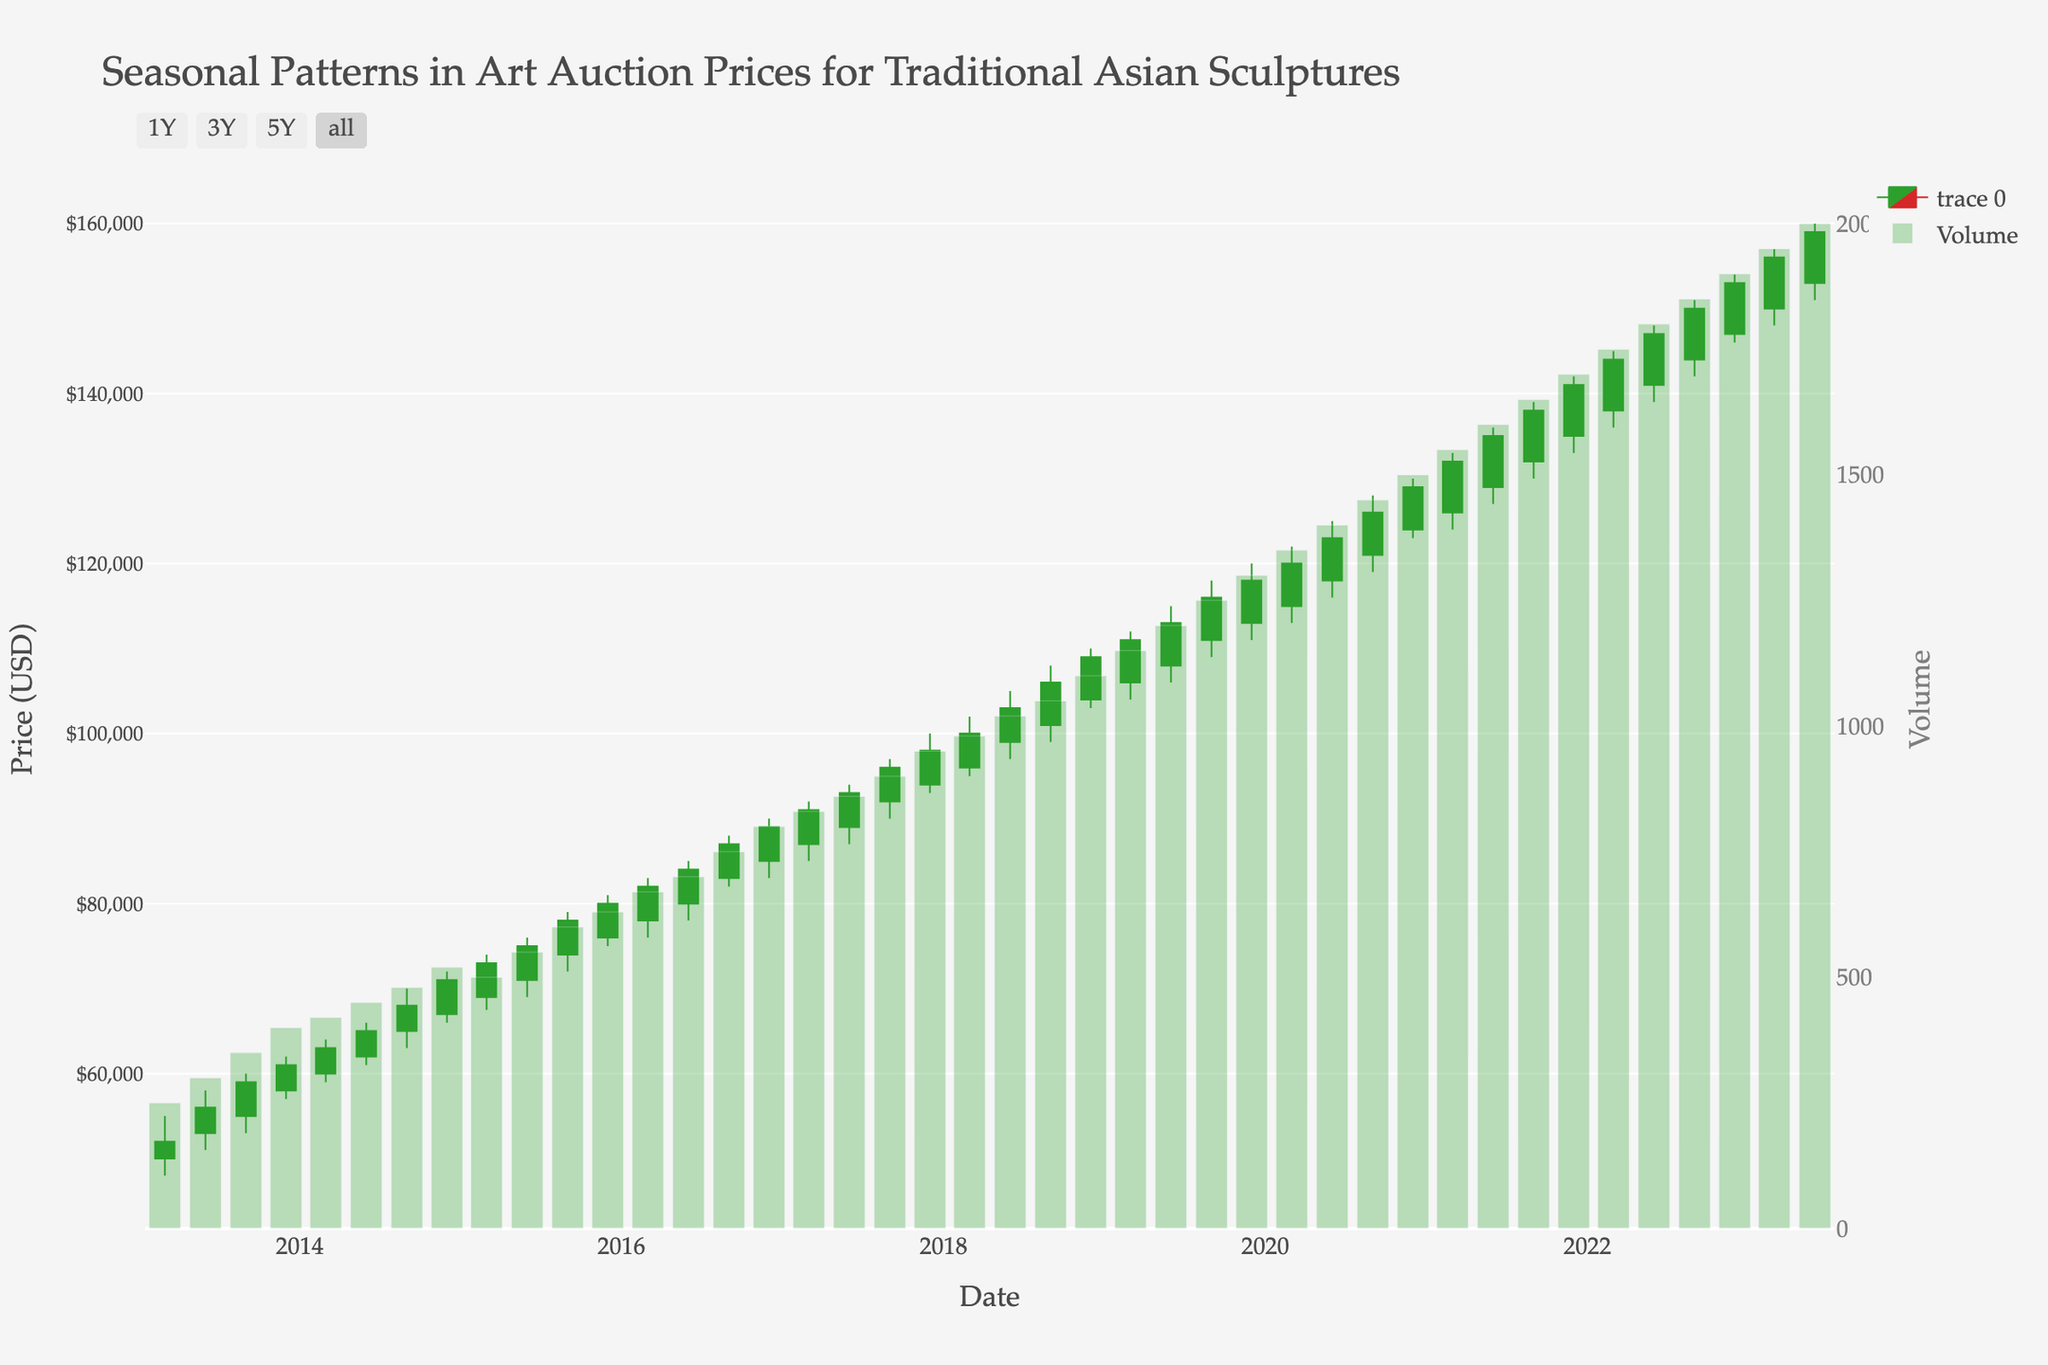What is the title of the figure? The title is located at the top center of the figure. It directly states the main theme of the chart.
Answer: Seasonal Patterns in Art Auction Prices for Traditional Asian Sculptures What are the labels on the x-axis and y-axis? The x-axis label is for time-related information while the y-axis label pertains to price data. These labels are found below each axis.
Answer: Date and Price (USD) How does the price trend from 2013 to 2023? By observing the movement of the candlesticks from 2013 to 2023, we can see a general upward trend with minor fluctuations.
Answer: The price generally increases What is the volume of sales in December 2022? The bar corresponding to December 2022 will show the volume height, and hovering over it reveals the exact volume value.
Answer: 1900 Describe the color coding for the candlesticks. The figure uses green for increasing (Open to Close) prices and red for decreasing prices; this is consistent across the plot.
Answer: Green for increasing, red for decreasing When did the volume surpass 1300? We need to look for the first occurrence where a bar height exceeds the 1300 mark on the volume axis.
Answer: December 2019 What month and year did the price first reach $100,000? Look for the figure where the candlestick touches or exceeds $100,000, then identify the corresponding date on the x-axis.
Answer: March 2018 Compare the highest and lowest prices in 2020. Which one is greater? The highest price in 2020 (from the candlesticks in that year) is $130,000, while the lowest is $113,000, both of which can be verified by the top and bottom shadows of the candles.
Answer: Highest is greater at $130,000 What was the closing price in March 2020? Locate the candlestick for March 2020 and check the closing value at the end of the candlestick body.
Answer: $120,000 How does the closing price in June 2021 compare to the closing price in September 2021? Find the candlestick for June 2021 and note its closing price, compare it with the September 2021 closing price.
Answer: June 2021 is lower at $135,000, compared to September 2021 at $138,000 